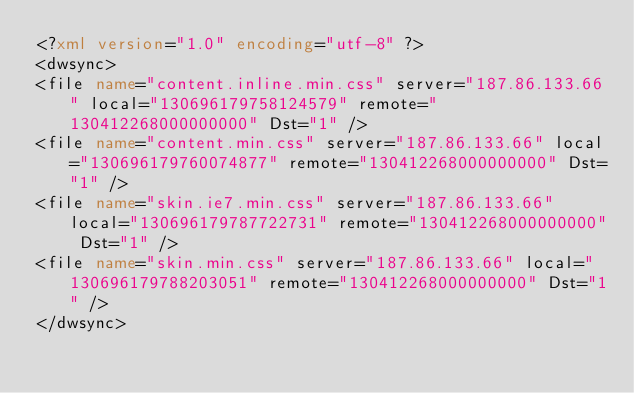<code> <loc_0><loc_0><loc_500><loc_500><_XML_><?xml version="1.0" encoding="utf-8" ?>
<dwsync>
<file name="content.inline.min.css" server="187.86.133.66" local="130696179758124579" remote="130412268000000000" Dst="1" />
<file name="content.min.css" server="187.86.133.66" local="130696179760074877" remote="130412268000000000" Dst="1" />
<file name="skin.ie7.min.css" server="187.86.133.66" local="130696179787722731" remote="130412268000000000" Dst="1" />
<file name="skin.min.css" server="187.86.133.66" local="130696179788203051" remote="130412268000000000" Dst="1" />
</dwsync></code> 